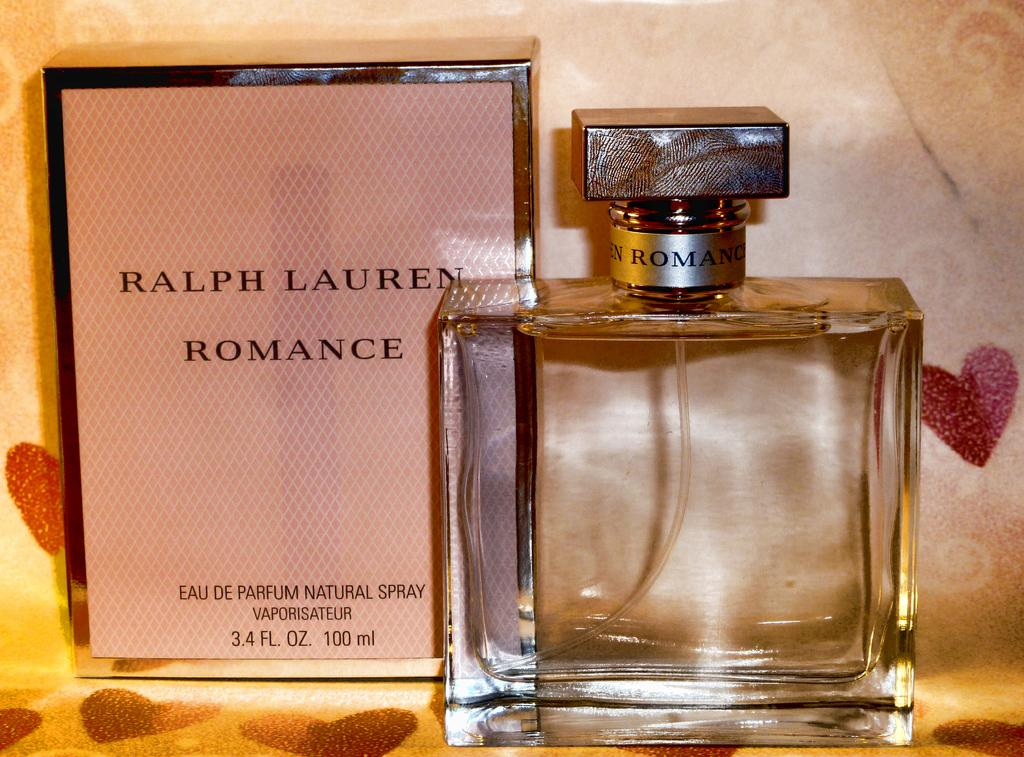<image>
Offer a succinct explanation of the picture presented. a bottle of the cologne named Romance by ralph lauren sitting next to its box. 